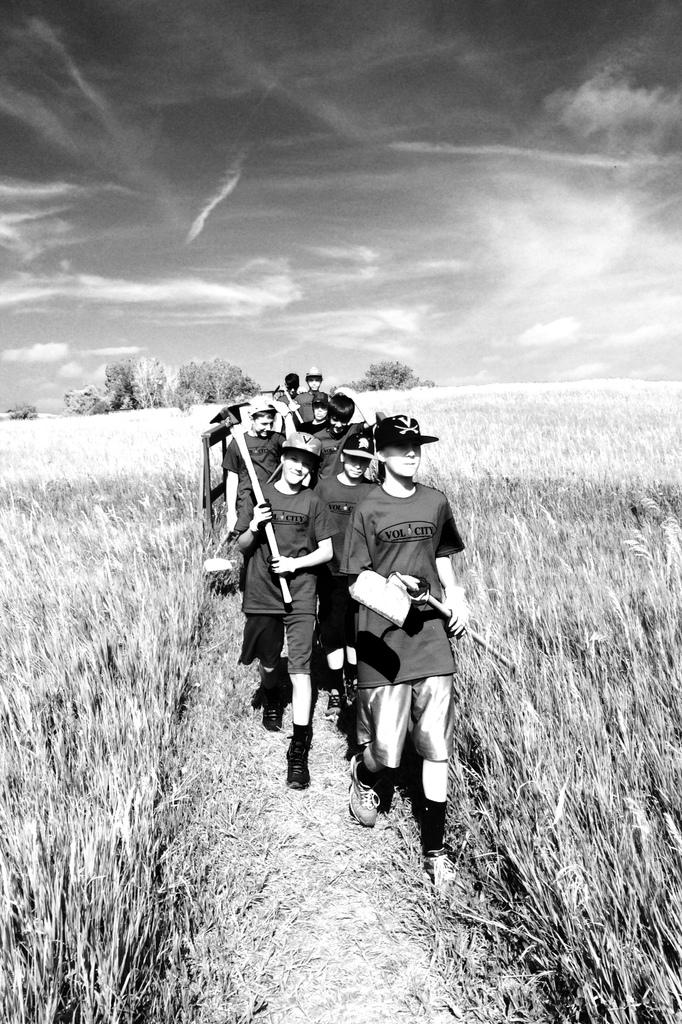How many people are in the image? There is a group of people in the image. What are the people wearing on their heads? The people are wearing caps. What are the people holding in their hands? The people are holding objects in their hands. What is the surface on which the people are walking? The people are walking on the ground. What type of vegetation can be seen in the background of the image? There are trees in the background of the image. What is visible in the sky in the background of the image? The sky is visible in the background of the image. What type of agreement is being discussed by the people in the image? There is no indication in the image that the people are discussing any agreements. 